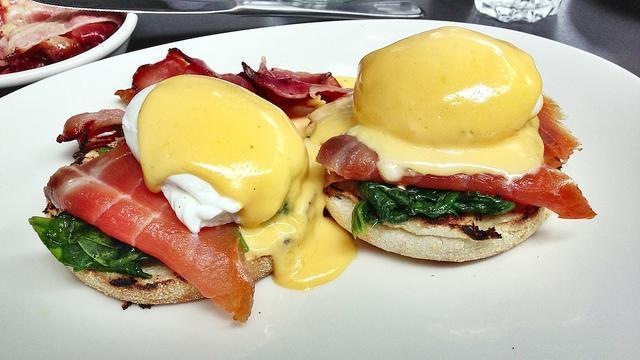What type of egg dish is shown?
From the following set of four choices, select the accurate answer to respond to the question.
Options: Fu yung, benedict, scrambled, omelette. Benedict. 